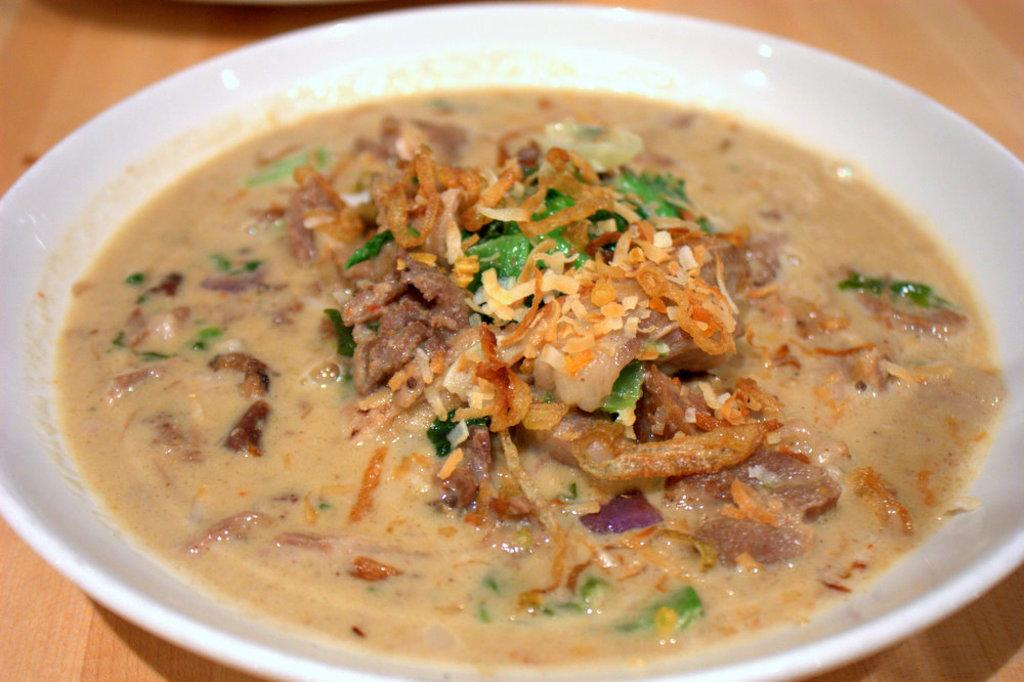What is the main subject of the image? There is a food item in the image. How is the food item presented? The food item is on a plate. Where is the plate with the food item located? The plate is on a table. What type of disease is affecting the food item in the image? There is no indication of any disease affecting the food item in the image. Who is the owner of the food item in the image? The image does not provide information about the owner of the food item. 